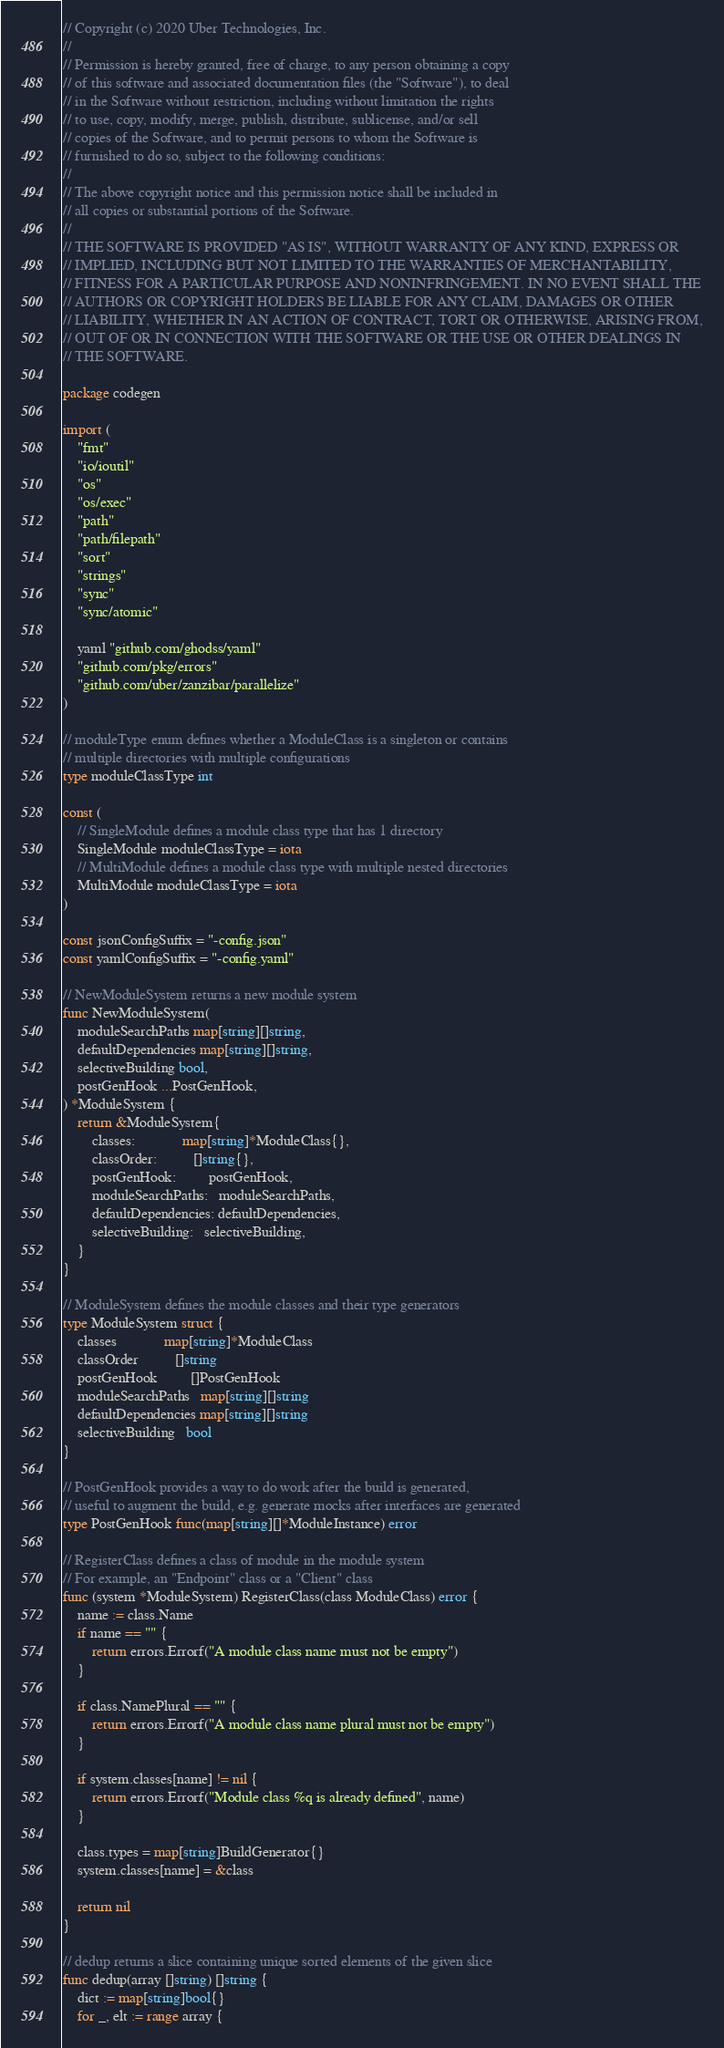<code> <loc_0><loc_0><loc_500><loc_500><_Go_>// Copyright (c) 2020 Uber Technologies, Inc.
//
// Permission is hereby granted, free of charge, to any person obtaining a copy
// of this software and associated documentation files (the "Software"), to deal
// in the Software without restriction, including without limitation the rights
// to use, copy, modify, merge, publish, distribute, sublicense, and/or sell
// copies of the Software, and to permit persons to whom the Software is
// furnished to do so, subject to the following conditions:
//
// The above copyright notice and this permission notice shall be included in
// all copies or substantial portions of the Software.
//
// THE SOFTWARE IS PROVIDED "AS IS", WITHOUT WARRANTY OF ANY KIND, EXPRESS OR
// IMPLIED, INCLUDING BUT NOT LIMITED TO THE WARRANTIES OF MERCHANTABILITY,
// FITNESS FOR A PARTICULAR PURPOSE AND NONINFRINGEMENT. IN NO EVENT SHALL THE
// AUTHORS OR COPYRIGHT HOLDERS BE LIABLE FOR ANY CLAIM, DAMAGES OR OTHER
// LIABILITY, WHETHER IN AN ACTION OF CONTRACT, TORT OR OTHERWISE, ARISING FROM,
// OUT OF OR IN CONNECTION WITH THE SOFTWARE OR THE USE OR OTHER DEALINGS IN
// THE SOFTWARE.

package codegen

import (
	"fmt"
	"io/ioutil"
	"os"
	"os/exec"
	"path"
	"path/filepath"
	"sort"
	"strings"
	"sync"
	"sync/atomic"

	yaml "github.com/ghodss/yaml"
	"github.com/pkg/errors"
	"github.com/uber/zanzibar/parallelize"
)

// moduleType enum defines whether a ModuleClass is a singleton or contains
// multiple directories with multiple configurations
type moduleClassType int

const (
	// SingleModule defines a module class type that has 1 directory
	SingleModule moduleClassType = iota
	// MultiModule defines a module class type with multiple nested directories
	MultiModule moduleClassType = iota
)

const jsonConfigSuffix = "-config.json"
const yamlConfigSuffix = "-config.yaml"

// NewModuleSystem returns a new module system
func NewModuleSystem(
	moduleSearchPaths map[string][]string,
	defaultDependencies map[string][]string,
	selectiveBuilding bool,
	postGenHook ...PostGenHook,
) *ModuleSystem {
	return &ModuleSystem{
		classes:             map[string]*ModuleClass{},
		classOrder:          []string{},
		postGenHook:         postGenHook,
		moduleSearchPaths:   moduleSearchPaths,
		defaultDependencies: defaultDependencies,
		selectiveBuilding:   selectiveBuilding,
	}
}

// ModuleSystem defines the module classes and their type generators
type ModuleSystem struct {
	classes             map[string]*ModuleClass
	classOrder          []string
	postGenHook         []PostGenHook
	moduleSearchPaths   map[string][]string
	defaultDependencies map[string][]string
	selectiveBuilding   bool
}

// PostGenHook provides a way to do work after the build is generated,
// useful to augment the build, e.g. generate mocks after interfaces are generated
type PostGenHook func(map[string][]*ModuleInstance) error

// RegisterClass defines a class of module in the module system
// For example, an "Endpoint" class or a "Client" class
func (system *ModuleSystem) RegisterClass(class ModuleClass) error {
	name := class.Name
	if name == "" {
		return errors.Errorf("A module class name must not be empty")
	}

	if class.NamePlural == "" {
		return errors.Errorf("A module class name plural must not be empty")
	}

	if system.classes[name] != nil {
		return errors.Errorf("Module class %q is already defined", name)
	}

	class.types = map[string]BuildGenerator{}
	system.classes[name] = &class

	return nil
}

// dedup returns a slice containing unique sorted elements of the given slice
func dedup(array []string) []string {
	dict := map[string]bool{}
	for _, elt := range array {</code> 